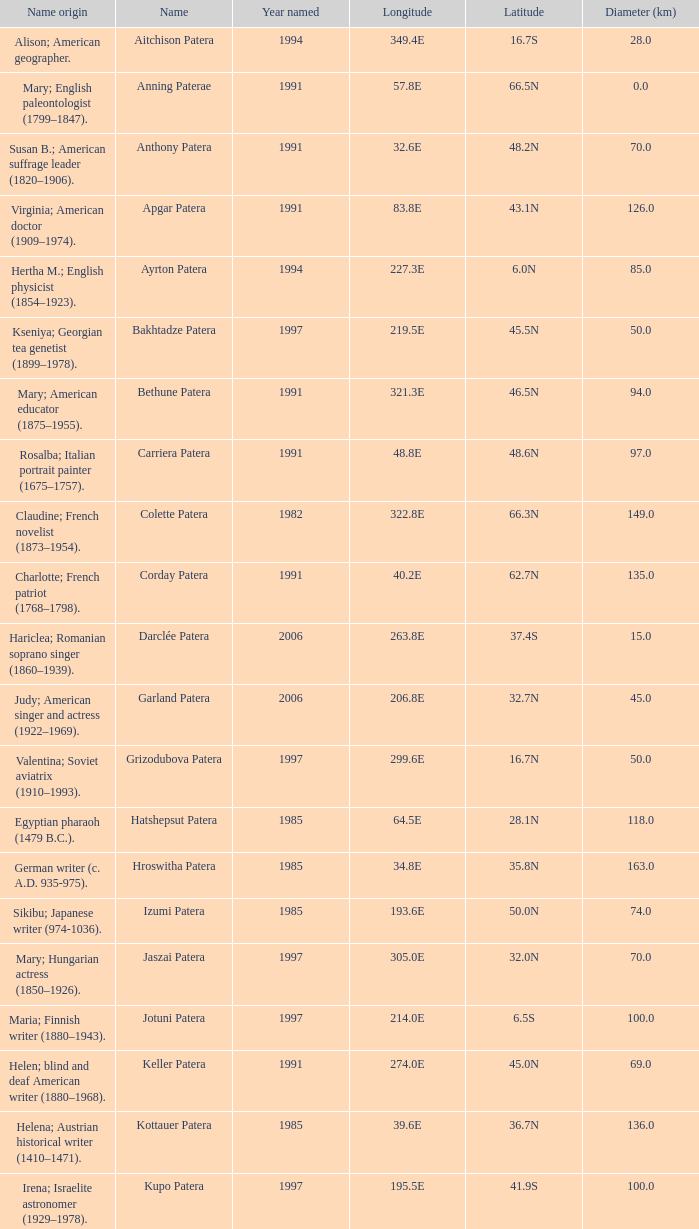What is the longitude of the feature named Razia Patera?  197.8E. 